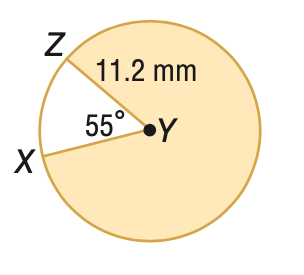Answer the mathemtical geometry problem and directly provide the correct option letter.
Question: Find the area of the shaded sector. Round to the nearest tenth, if necessary.
Choices: A: 10.8 B: 59.6 C: 60.2 D: 333.9 D 